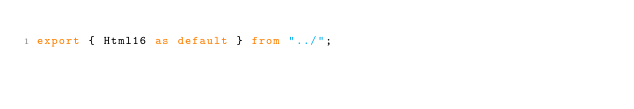<code> <loc_0><loc_0><loc_500><loc_500><_TypeScript_>export { Html16 as default } from "../";
</code> 